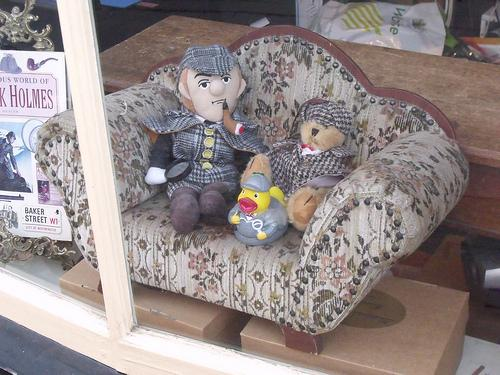How is Sherlock Holmes represented in the toys displayed? Sherlock Holmes is represented by a doll wearing a deerstalker hat and a pipe in its mouth, as well as by other toys inspired by his characteristics. Describe the appearance of the couch in the image. The couch is small, floral printed, and upholstered, with wooden legs, and is placed on a wooden platform. Briefly explain the scene you observe in the image. This scene showcases a selection of Sherlock Holmes-themed toys, including dolls and stuffed animals, displayed on a small toy couch in a store window. What is the purpose of the setup in the image? The setup is an advertisement for the Sherlock Holmes-themed stuffed toys and dolls, displayed in a store window. What do all these toys in the image have in common? All the toys are dressed as characters from the Sherlock Holmes stories, such as Sherlock Holmes, Dr. Watson, and a detective rubber duck. What emotions do the toys in this image evoke? The toys evoke a playful and nostalgic feeling, as they represent characters from popular detective stories in a cute, childlike manner. Name a popular character that is represented by the toys in this picture. Sherlock Holmes is represented by several toys in this picture, including dolls and stuffed animals. Identify an accessory that a toy in the image is holding. The detective rubber duck is holding a tiny white magnifying glass. Mention a unique detail observed in the image related to a toy. A yellow rubber ducky wearing a deerstalker hat and holding a tiny white magnifying glass is part of the detective-themed toy setup. Describe the location where this image might have been taken. This image is likely taken in front of a store that sells toys, with the detective-themed toy display visible through the storefront window. 